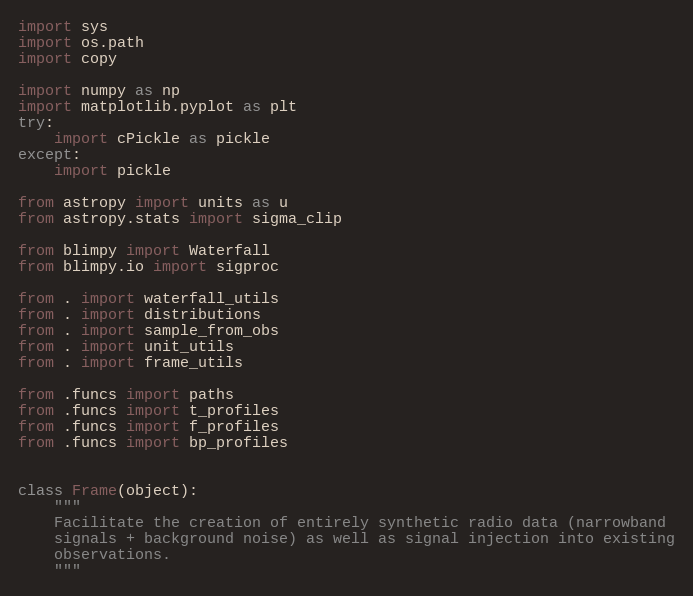Convert code to text. <code><loc_0><loc_0><loc_500><loc_500><_Python_>import sys
import os.path
import copy

import numpy as np
import matplotlib.pyplot as plt
try:
    import cPickle as pickle
except:
    import pickle

from astropy import units as u
from astropy.stats import sigma_clip

from blimpy import Waterfall
from blimpy.io import sigproc

from . import waterfall_utils
from . import distributions
from . import sample_from_obs
from . import unit_utils
from . import frame_utils

from .funcs import paths
from .funcs import t_profiles
from .funcs import f_profiles
from .funcs import bp_profiles


class Frame(object):
    """
    Facilitate the creation of entirely synthetic radio data (narrowband
    signals + background noise) as well as signal injection into existing
    observations.
    """
</code> 